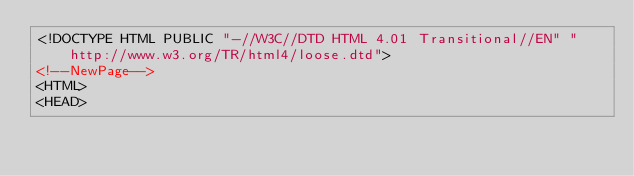Convert code to text. <code><loc_0><loc_0><loc_500><loc_500><_HTML_><!DOCTYPE HTML PUBLIC "-//W3C//DTD HTML 4.01 Transitional//EN" "http://www.w3.org/TR/html4/loose.dtd">
<!--NewPage-->
<HTML>
<HEAD></code> 